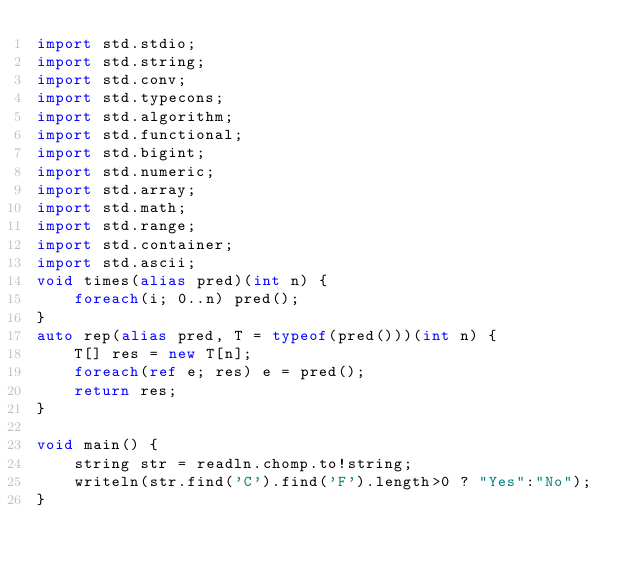<code> <loc_0><loc_0><loc_500><loc_500><_D_>import std.stdio;
import std.string;
import std.conv;
import std.typecons;
import std.algorithm;
import std.functional;
import std.bigint;
import std.numeric;
import std.array;
import std.math;
import std.range;
import std.container;
import std.ascii;
void times(alias pred)(int n) {
    foreach(i; 0..n) pred();
}
auto rep(alias pred, T = typeof(pred()))(int n) {
    T[] res = new T[n];
    foreach(ref e; res) e = pred();
    return res;
}

void main() {
    string str = readln.chomp.to!string;
    writeln(str.find('C').find('F').length>0 ? "Yes":"No");
}
</code> 